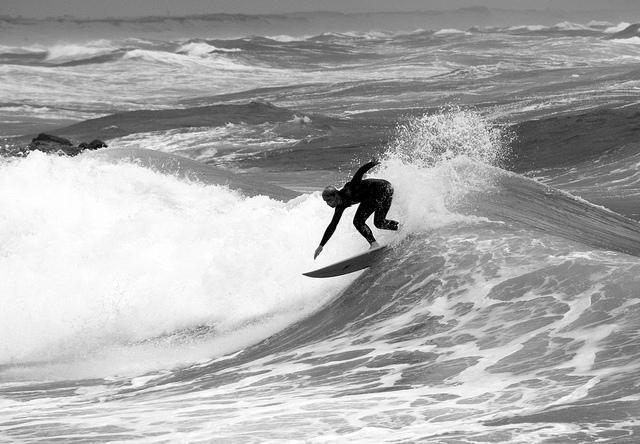How many people are in the photo?
Give a very brief answer. 1. 